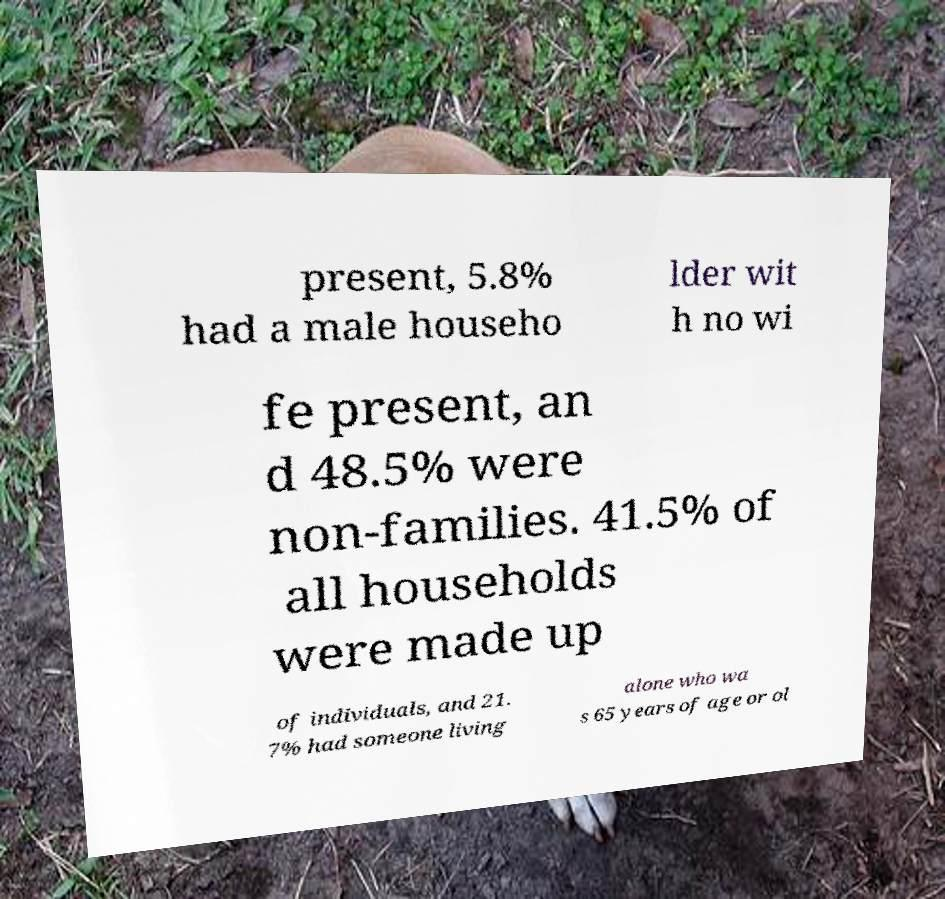I need the written content from this picture converted into text. Can you do that? present, 5.8% had a male househo lder wit h no wi fe present, an d 48.5% were non-families. 41.5% of all households were made up of individuals, and 21. 7% had someone living alone who wa s 65 years of age or ol 